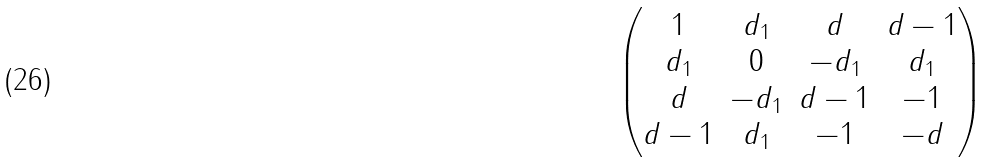<formula> <loc_0><loc_0><loc_500><loc_500>\begin{pmatrix} 1 & d _ { 1 } & d & d - 1 \\ d _ { 1 } & 0 & - d _ { 1 } & d _ { 1 } \\ d & - d _ { 1 } & d - 1 & - 1 \\ d - 1 & d _ { 1 } & - 1 & - d \end{pmatrix}</formula> 